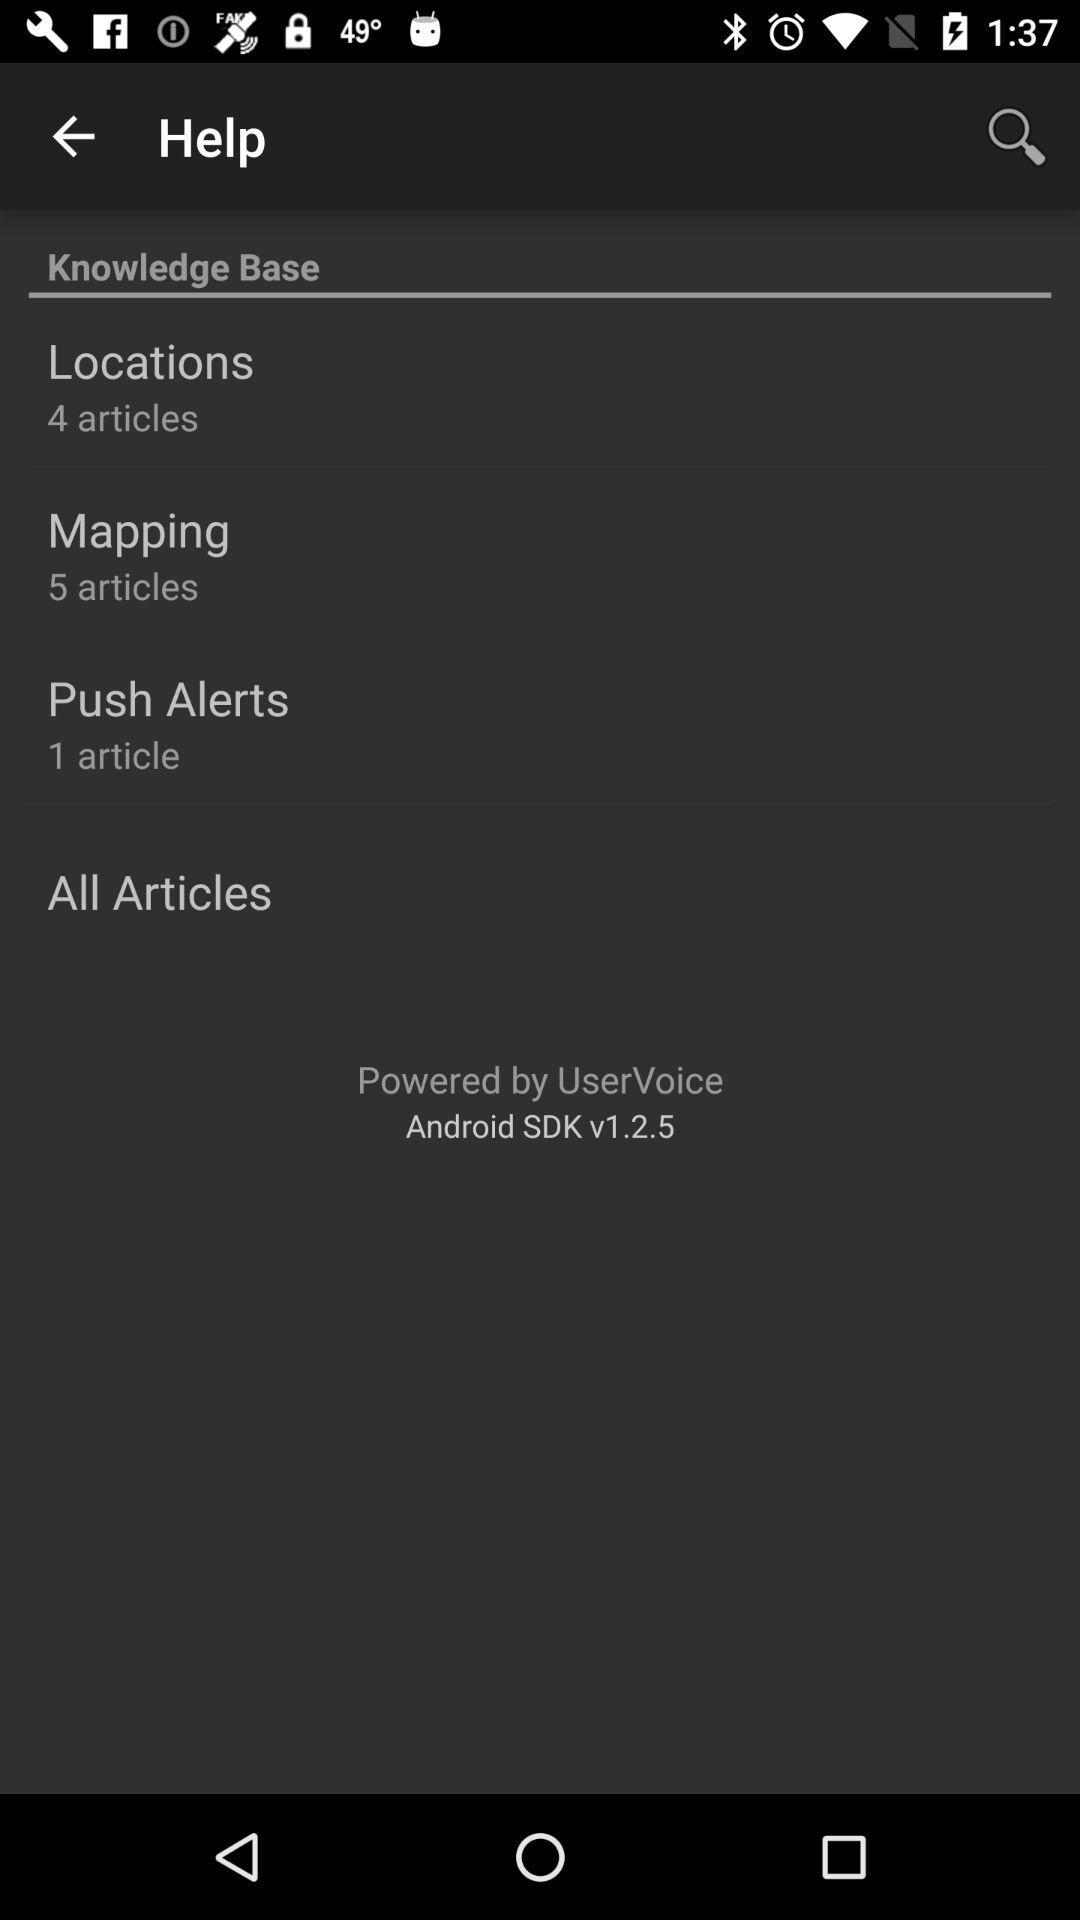How many articles are there in the mapping? There are 5 articles in the mapping. 